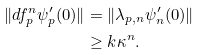Convert formula to latex. <formula><loc_0><loc_0><loc_500><loc_500>\| d f ^ { n } _ { p } \psi ^ { \prime } _ { p } ( 0 ) \| & = \| \lambda _ { p , n } \psi ^ { \prime } _ { n } ( 0 ) \| \\ & \geq k \kappa ^ { n } .</formula> 